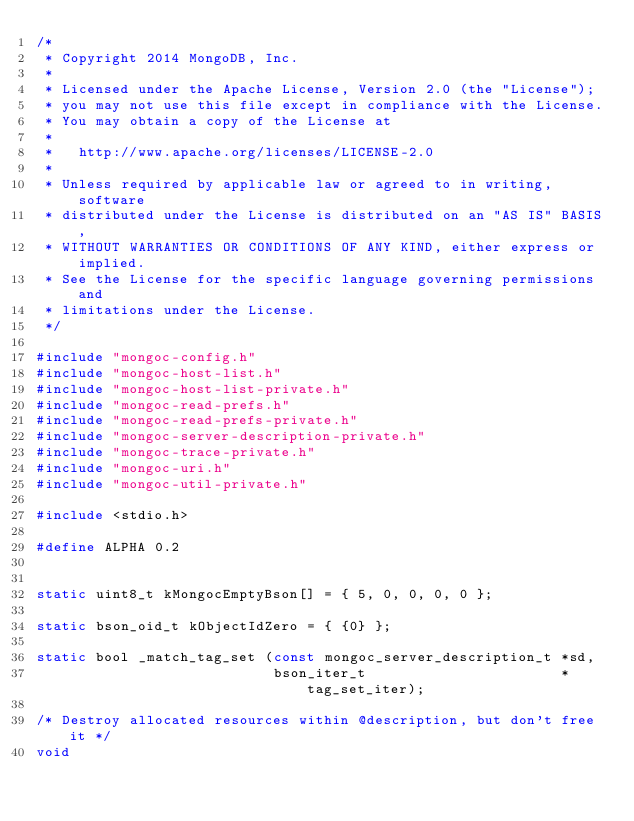<code> <loc_0><loc_0><loc_500><loc_500><_C_>/*
 * Copyright 2014 MongoDB, Inc.
 *
 * Licensed under the Apache License, Version 2.0 (the "License");
 * you may not use this file except in compliance with the License.
 * You may obtain a copy of the License at
 *
 *   http://www.apache.org/licenses/LICENSE-2.0
 *
 * Unless required by applicable law or agreed to in writing, software
 * distributed under the License is distributed on an "AS IS" BASIS,
 * WITHOUT WARRANTIES OR CONDITIONS OF ANY KIND, either express or implied.
 * See the License for the specific language governing permissions and
 * limitations under the License.
 */

#include "mongoc-config.h"
#include "mongoc-host-list.h"
#include "mongoc-host-list-private.h"
#include "mongoc-read-prefs.h"
#include "mongoc-read-prefs-private.h"
#include "mongoc-server-description-private.h"
#include "mongoc-trace-private.h"
#include "mongoc-uri.h"
#include "mongoc-util-private.h"

#include <stdio.h>

#define ALPHA 0.2


static uint8_t kMongocEmptyBson[] = { 5, 0, 0, 0, 0 };

static bson_oid_t kObjectIdZero = { {0} };

static bool _match_tag_set (const mongoc_server_description_t *sd,
                            bson_iter_t                       *tag_set_iter);

/* Destroy allocated resources within @description, but don't free it */
void</code> 